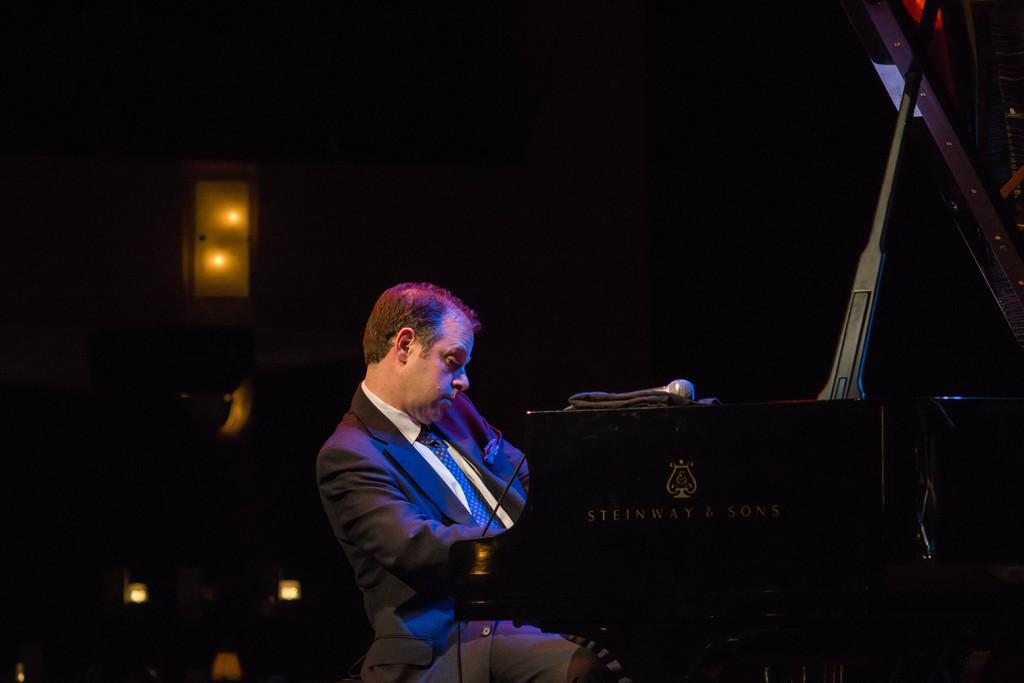What is the man in the image doing? The man is sitting in front of a piano. What can be seen on the left side of the image? There are lights on the left side of the image. How would you describe the overall lighting in the image? The background of the image is dark. What object is present on the piano? There appears to be a microphone on the piano. Is the man holding an umbrella in the image? No, there is no umbrella present in the image. How does the man's health appear to be in the image? The image does not provide any information about the man's health. 